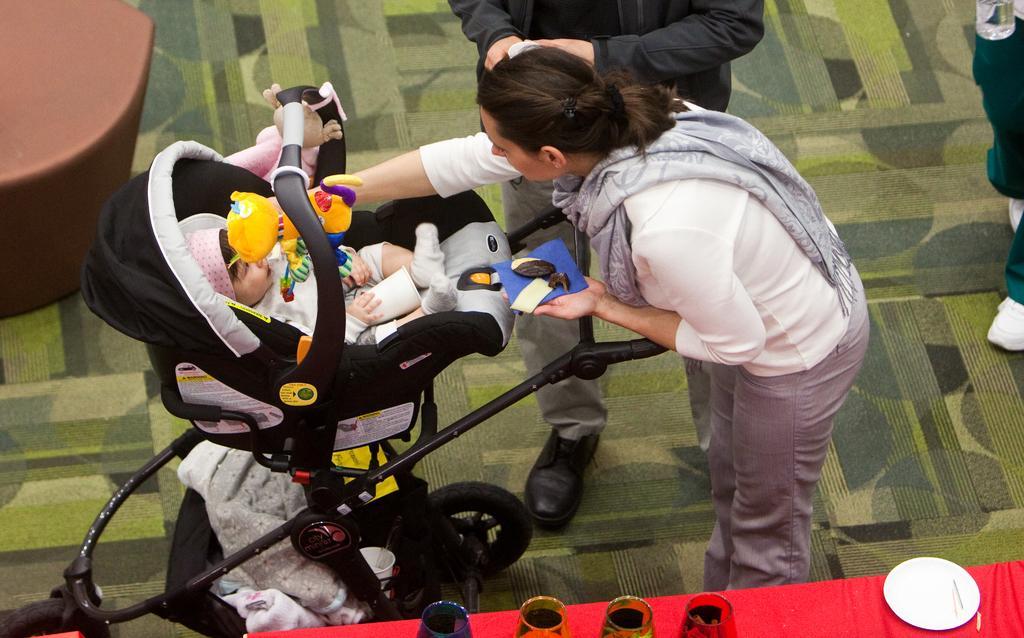How would you summarize this image in a sentence or two? There is a lady wearing scarf and holding something in the hand. There is a stroller with a baby. On the stroller there is a toy and some other things. There is a table. On the table there are some items. Also there is another person standing. On the left side there is a brown color object. 